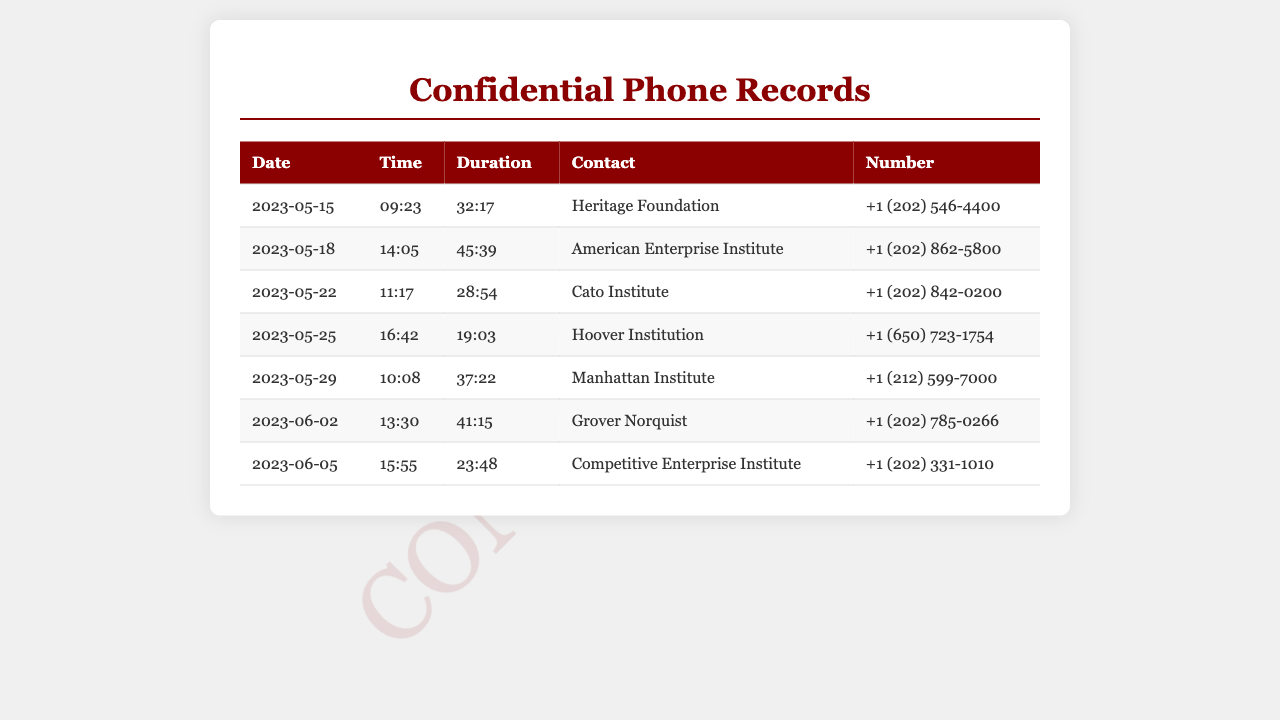What is the date of the first call? The first call is listed as happening on May 15, 2023.
Answer: May 15, 2023 Which conservative think tank was contacted on May 18, 2023? The contact on May 18, 2023, was with the American Enterprise Institute.
Answer: American Enterprise Institute What was the duration of the call with Grover Norquist? The document states that the call with Grover Norquist lasted for 41 minutes and 15 seconds.
Answer: 41:15 How many times did the politician communicate with the Cato Institute? The Cato Institute is listed as having been contacted once in the records provided.
Answer: Once What is the phone number for the Heritage Foundation? The contact number for the Heritage Foundation is listed as +1 (202) 546-4400.
Answer: +1 (202) 546-4400 What contact occurred on June 5, 2023? The document shows a call with the Competitive Enterprise Institute on June 5, 2023.
Answer: Competitive Enterprise Institute Which contact had the longest call duration, and what was that duration? The call with the American Enterprise Institute had the longest duration of 45 minutes and 39 seconds.
Answer: 45:39 How many unique contacts are listed in the phone records? There are 7 unique contacts listed in the records.
Answer: 7 